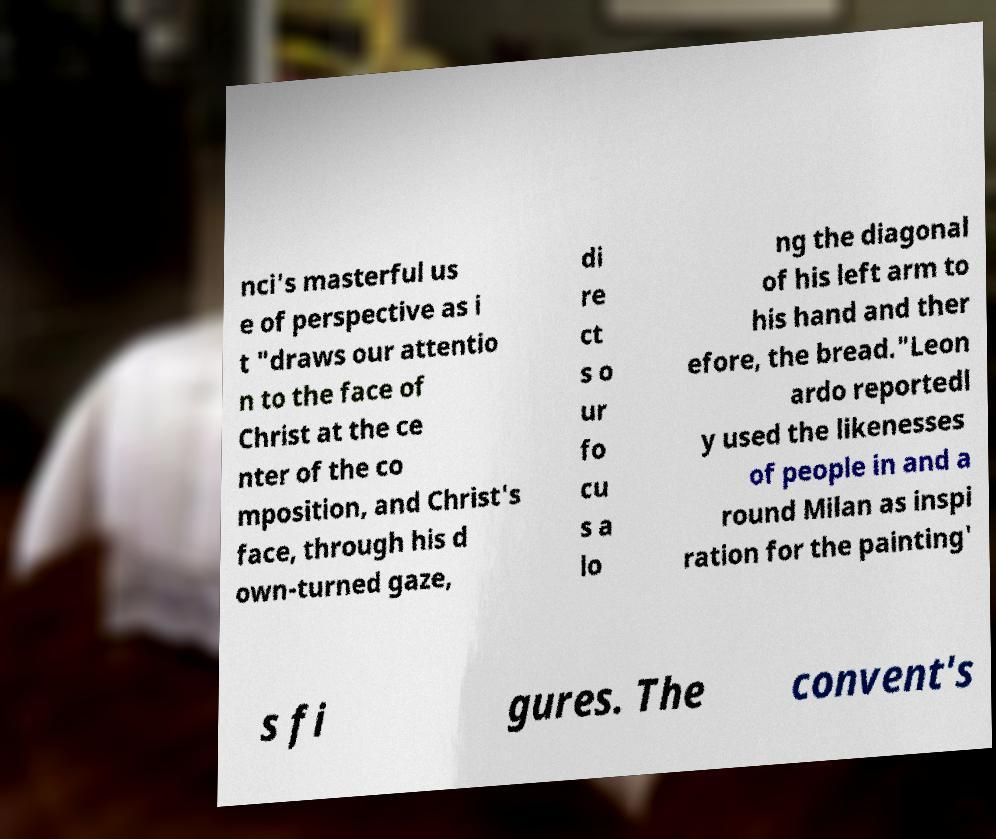Could you extract and type out the text from this image? nci's masterful us e of perspective as i t "draws our attentio n to the face of Christ at the ce nter of the co mposition, and Christ's face, through his d own-turned gaze, di re ct s o ur fo cu s a lo ng the diagonal of his left arm to his hand and ther efore, the bread."Leon ardo reportedl y used the likenesses of people in and a round Milan as inspi ration for the painting' s fi gures. The convent's 